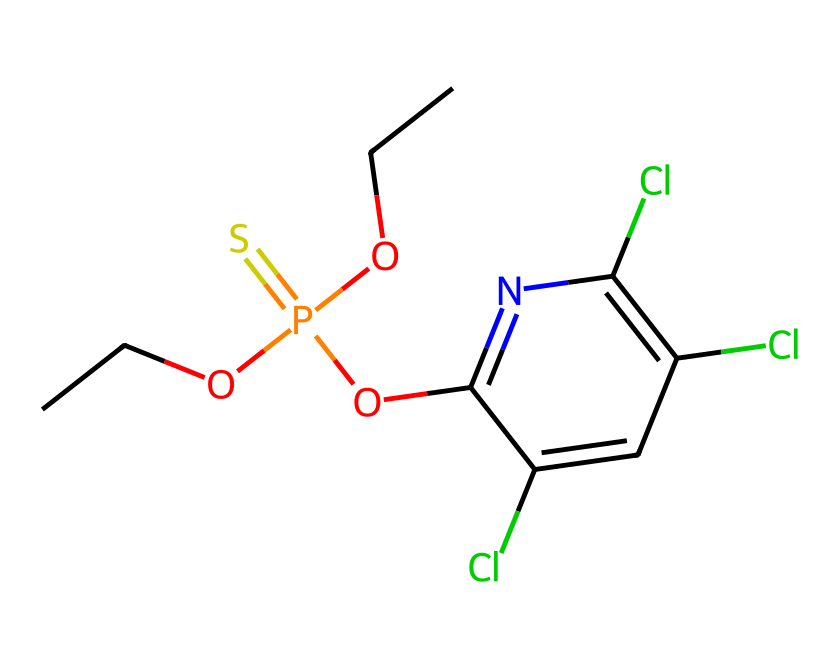what is the name of this chemical? The chemical structure corresponds to chlorpyrifos, which is identified from its typical arrangement and functional groups, specifically the organophosphate group in its structure.
Answer: chlorpyrifos how many chlorine atoms are present in this structure? By examining the visual representation of the chemical structure, we see three chlorine (Cl) atoms attached to the aromatic ring as substituents.
Answer: three what type of functional group is represented by the '-P(=S)(O)...' portion of the molecule? This portion indicates the presence of a phosphate group, specifically an organophosphate due to the sulfur and oxygen attachments, making it characteristic of pesticides.
Answer: organophosphate how many carbon atoms are there in chlorpyrifos? By counting the carbon atoms throughout the entire structure, including those in the aromatic ring and the aliphatic chains, there are a total of nine carbon (C) atoms present.
Answer: nine what effect might the presence of chlorine atoms have on chlorpyrifos' properties? The chlorine atoms increase the lipophilicity of chlorpyrifos, enhancing its ability to persist in the environment and affecting its toxicity profile as a pesticide.
Answer: lipophilicity what is the role of the 'O' in the central structure of this molecule? The 'O' (oxygen) atom indicates a bond to a phosphorus atom and facilitates the organophosphate activity by serving as a leaving group during the action against pests, affecting the enzyme acetylcholinesterase.
Answer: leaving group which part of the molecule is primarily responsible for its toxicity? The phosphorus atom's connectivity to the oxygen atoms and chlorinated aromatic structure contributes to the toxicity mechanism in disrupting nerve function by inhibiting acetylcholinesterase.
Answer: phosphorus atom 